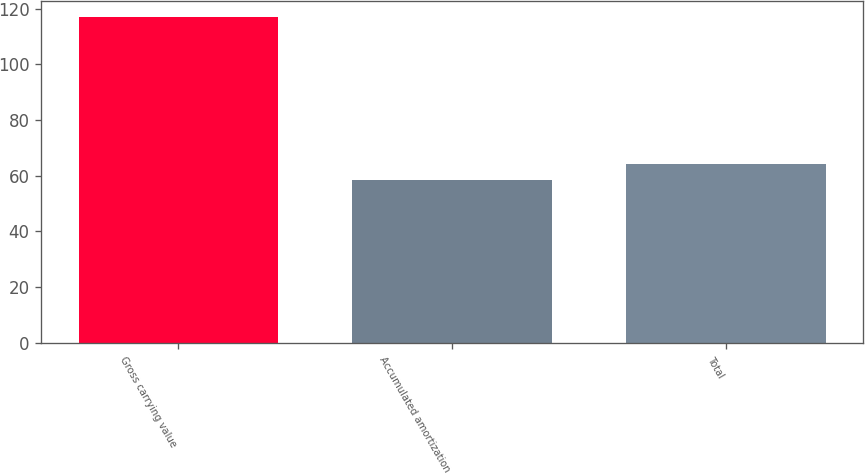Convert chart. <chart><loc_0><loc_0><loc_500><loc_500><bar_chart><fcel>Gross carrying value<fcel>Accumulated amortization<fcel>Total<nl><fcel>116.8<fcel>58.4<fcel>64.24<nl></chart> 